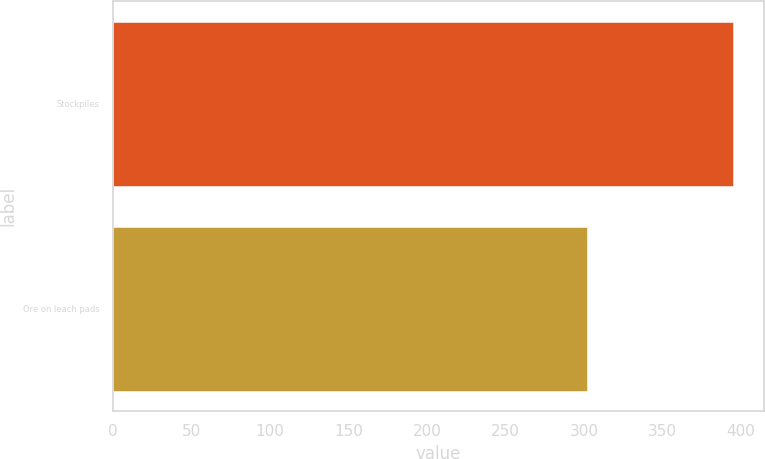Convert chart to OTSL. <chart><loc_0><loc_0><loc_500><loc_500><bar_chart><fcel>Stockpiles<fcel>Ore on leach pads<nl><fcel>395<fcel>302<nl></chart> 